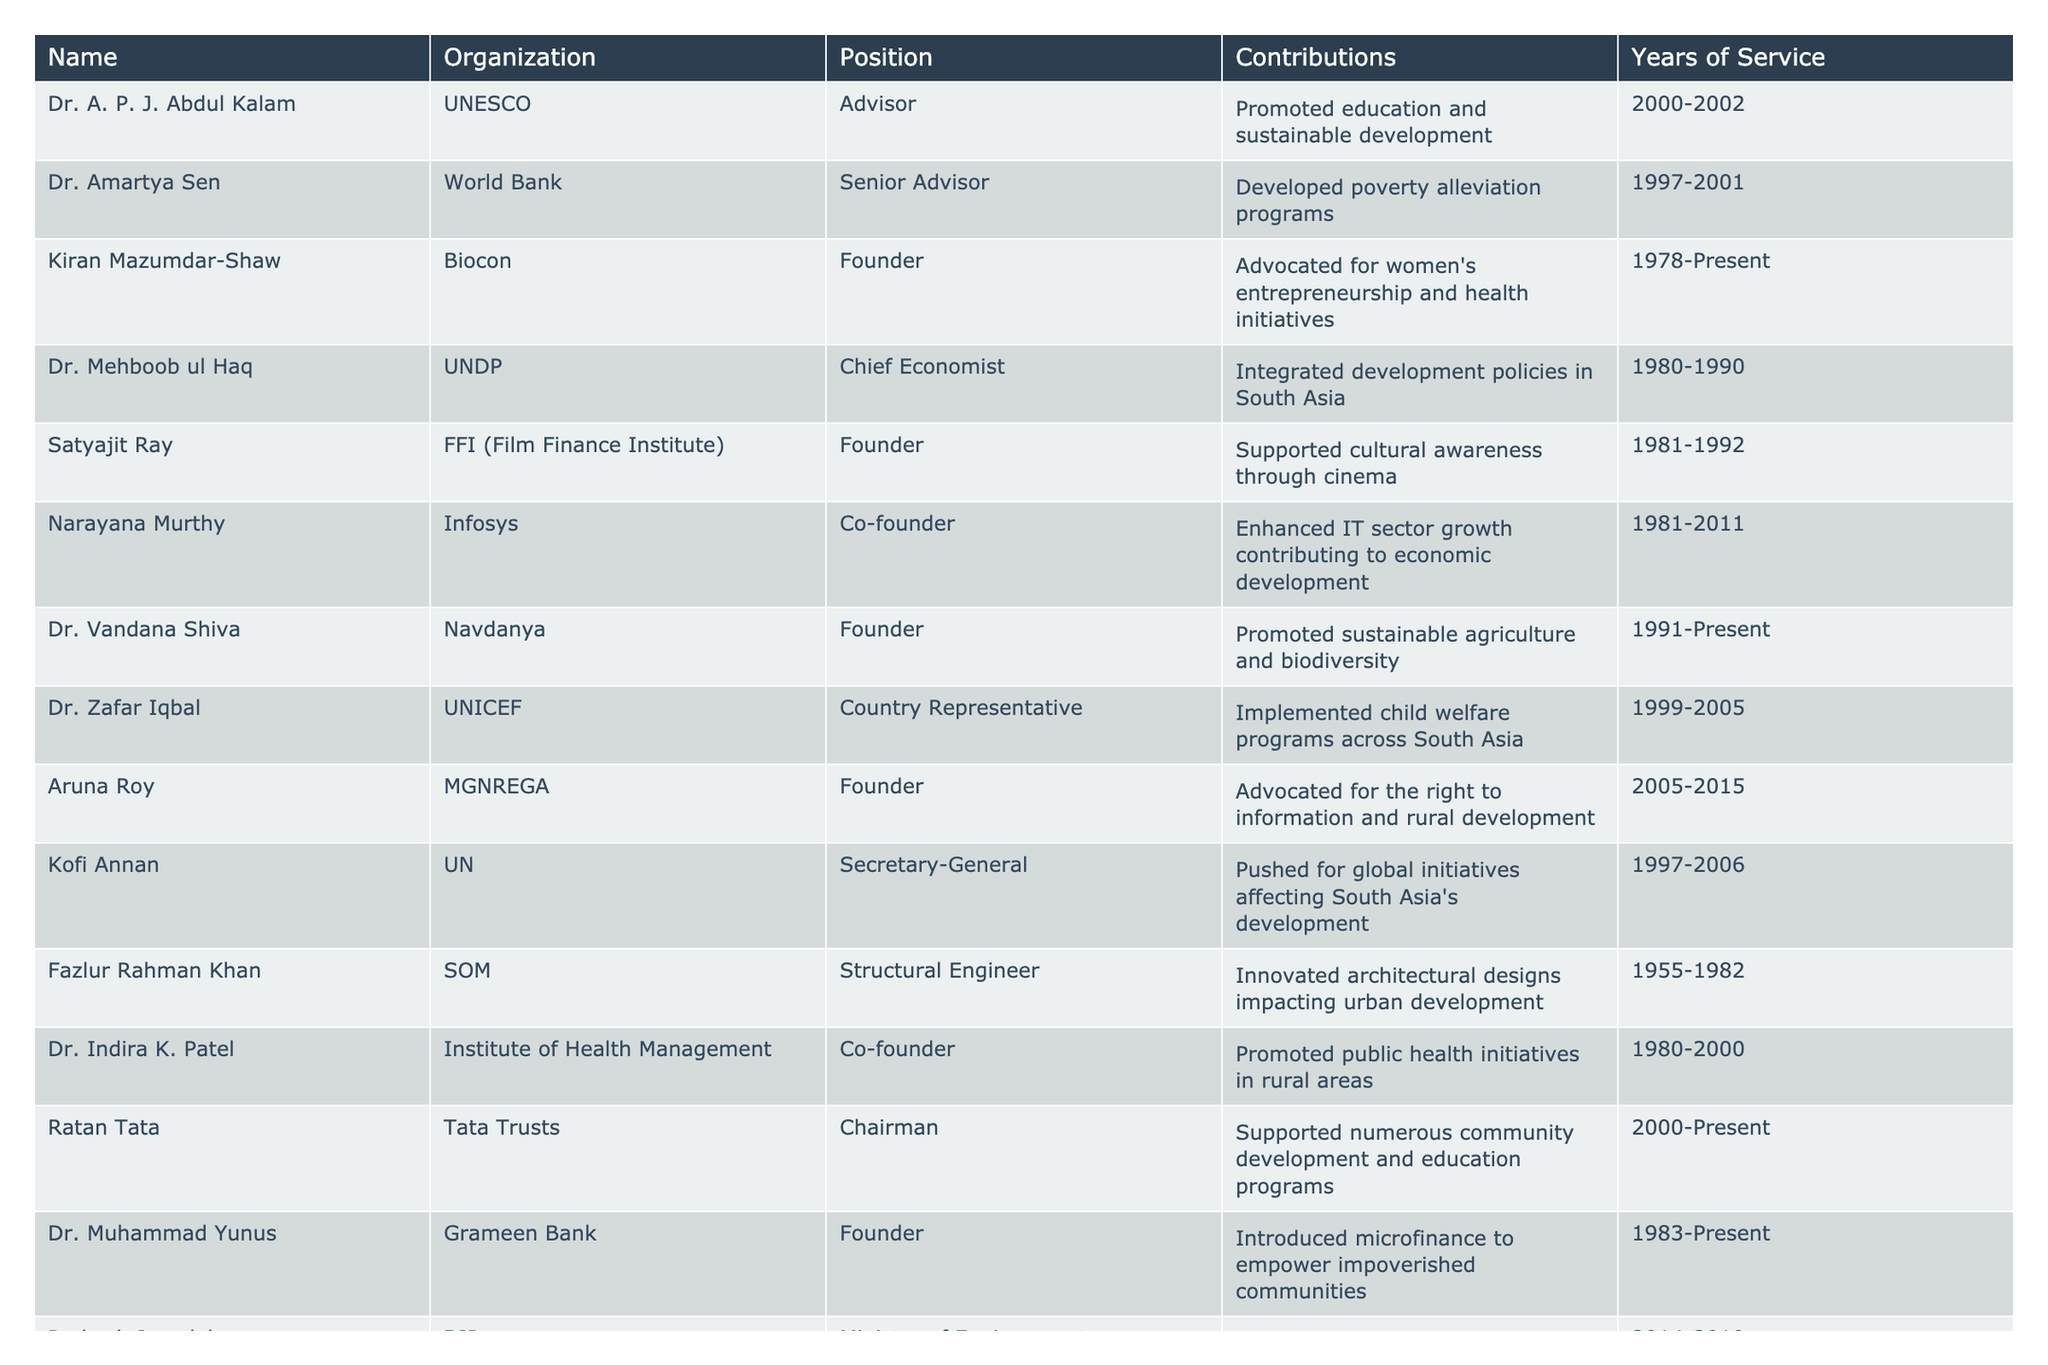What contributions did Dr. A. P. J. Abdul Kalam make during his service? According to the table, Dr. A. P. J. Abdul Kalam served as an advisor at UNESCO from 2000 to 2002 and promoted education and sustainable development during that time.
Answer: Promoted education and sustainable development Who was the country representative of UNICEF from 1999 to 2005? The table states that Dr. Zafar Iqbal held the position of Country Representative for UNICEF between 1999 and 2005.
Answer: Dr. Zafar Iqbal How many years of service did Kiran Mazumdar-Shaw complete by 2023? Kiran Mazumdar-Shaw founded Biocon in 1978 and has been serving since then till the present year (2023). Therefore, her years of service amount to 2023 - 1978 = 45 years.
Answer: 45 years Did Narayana Murthy contribute to the IT sector? The table mentions that Narayana Murthy, as a co-founder of Infosys, enhanced IT sector growth, contributing to economic development. This indicates that he did contribute to the IT sector.
Answer: Yes What is the total number of years of service contributed by Dr. Mehboob ul Haq and Dr. Indira K. Patel combined? Dr. Mehboob ul Haq served from 1980 to 1990 (10 years) and Dr. Indira K. Patel served from 1980 to 2000 (20 years). Adding them gives 10 + 20 = 30 years of combined service.
Answer: 30 years Which figure has been serving in the development sector the longest? To find the longest-serving figure, we compare years of service. Kiran Mazumdar-Shaw (1978-Present) has served the longest, totaling 45 years by 2023.
Answer: Kiran Mazumdar-Shaw What type of initiatives did Dr. Vandana Shiva promote? The table states that Dr. Vandana Shiva, founder of Navdanya since 1991, promoted sustainable agriculture and biodiversity.
Answer: Sustainable agriculture and biodiversity How many notable figures listed have had service years extend to the present (2023)? By reviewing the table, we see Kiran Mazumdar-Shaw, Dr. Vandana Shiva, Ratan Tata, and Dr. Muhammad Yunus are all noted to have ongoing service. This totals to four figures.
Answer: Four figures What was the role of Kofi Annan concerning South Asia? According to the table, Kofi Annan served as Secretary-General at the UN from 1997 to 2006, during which he pushed for global initiatives affecting South Asia's development.
Answer: Pushed for global initiatives affecting South Asia's development Was Fazlur Rahman Khan involved in public health initiatives? Based on the table, Fazlur Rahman Khan is identified as a Structural Engineer involved in architectural designs impacting urban development, not public health initiatives.
Answer: No 